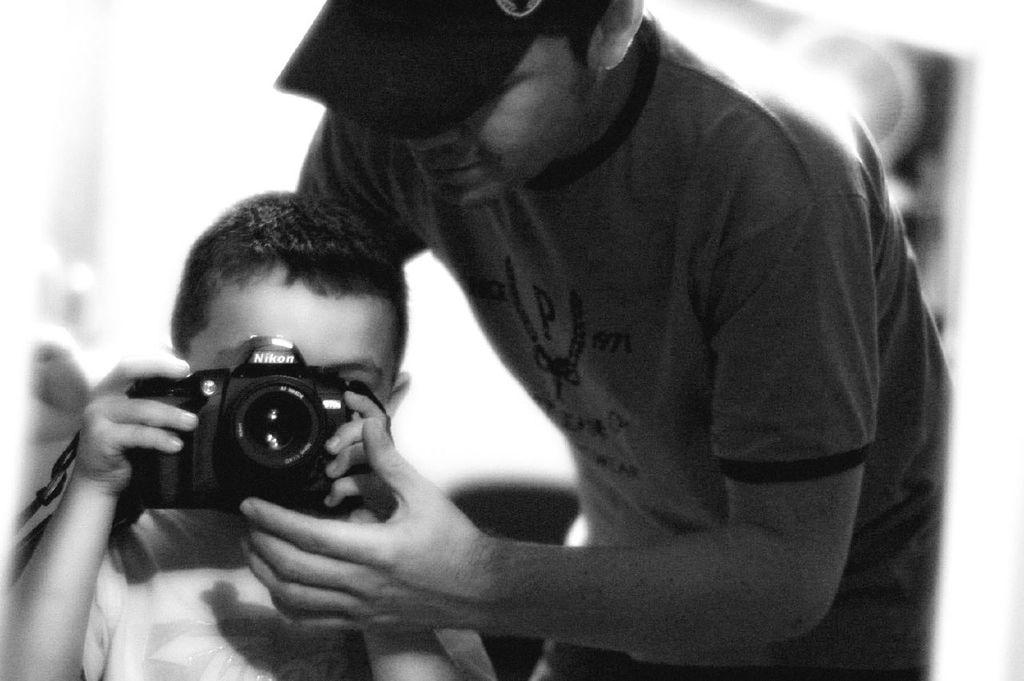Who is the main subject in the image? There is a boy in the image. What is the boy holding in the image? The boy is holding a camera. Can you describe the other person in the image? There is a person standing in the image. What type of iron can be seen in the image? There is no iron present in the image. How many stamps are visible on the person standing in the image? There are no stamps visible on the person standing in the image. 